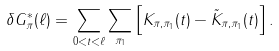<formula> <loc_0><loc_0><loc_500><loc_500>\delta G ^ { * } _ { \pi } ( \ell ) = \sum _ { 0 < t < \ell } \sum _ { \pi _ { 1 } } \left [ K _ { \pi , \pi _ { 1 } } ( t ) - \tilde { K } _ { \pi , \pi _ { 1 } } ( t ) \right ] .</formula> 